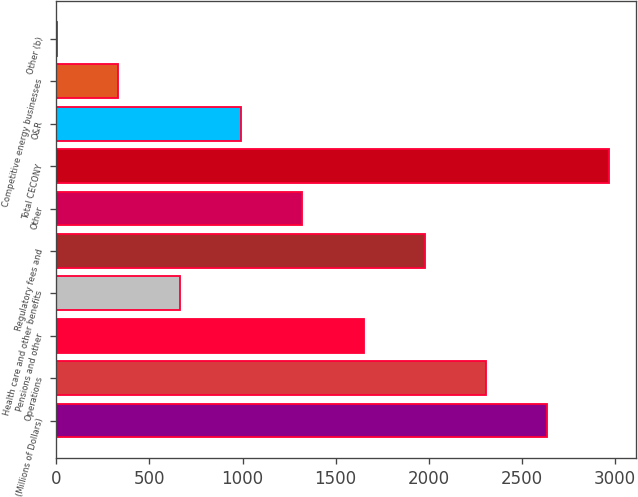Convert chart to OTSL. <chart><loc_0><loc_0><loc_500><loc_500><bar_chart><fcel>(Millions of Dollars)<fcel>Operations<fcel>Pensions and other<fcel>Health care and other benefits<fcel>Regulatory fees and<fcel>Other<fcel>Total CECONY<fcel>O&R<fcel>Competitive energy businesses<fcel>Other (b)<nl><fcel>2636.2<fcel>2307.3<fcel>1649.5<fcel>662.8<fcel>1978.4<fcel>1320.6<fcel>2965.1<fcel>991.7<fcel>333.9<fcel>5<nl></chart> 